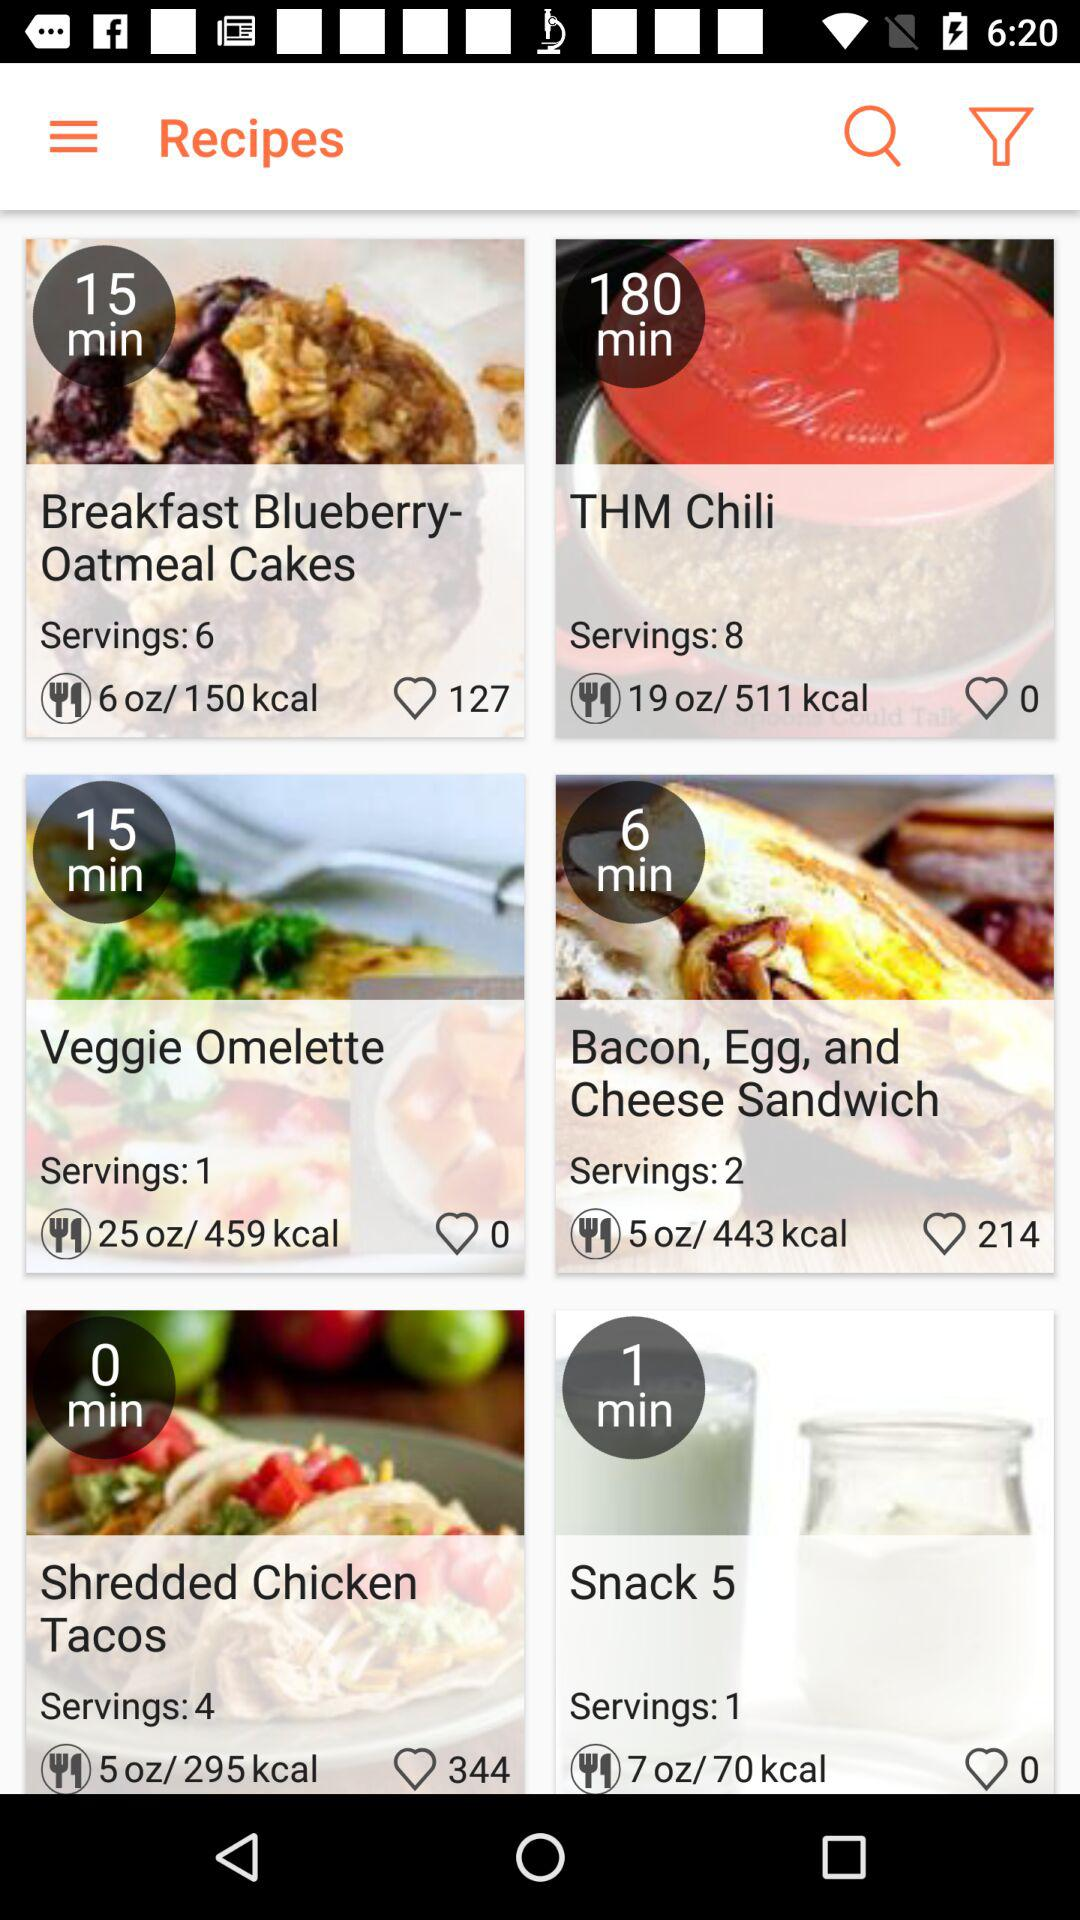How many "Snack 5" items can be served? The number of "Snack 5" items that can be served is 1. 